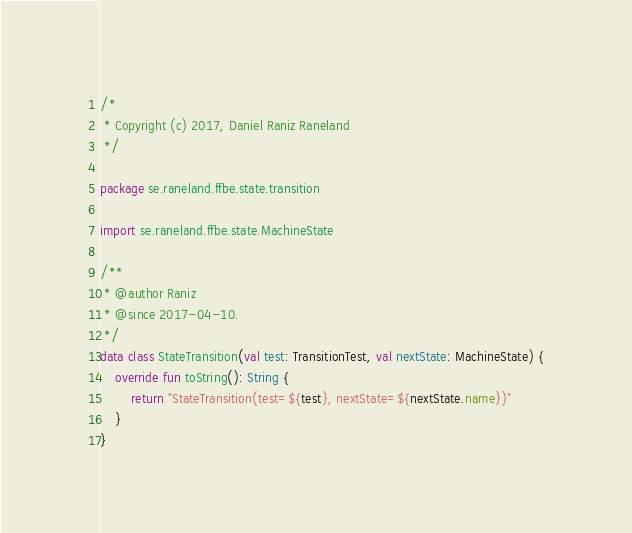Convert code to text. <code><loc_0><loc_0><loc_500><loc_500><_Kotlin_>/*
 * Copyright (c) 2017, Daniel Raniz Raneland
 */

package se.raneland.ffbe.state.transition

import se.raneland.ffbe.state.MachineState

/**
 * @author Raniz
 * @since 2017-04-10.
 */
data class StateTransition(val test: TransitionTest, val nextState: MachineState) {
    override fun toString(): String {
        return "StateTransition(test=${test}, nextState=${nextState.name})"
    }
}
</code> 